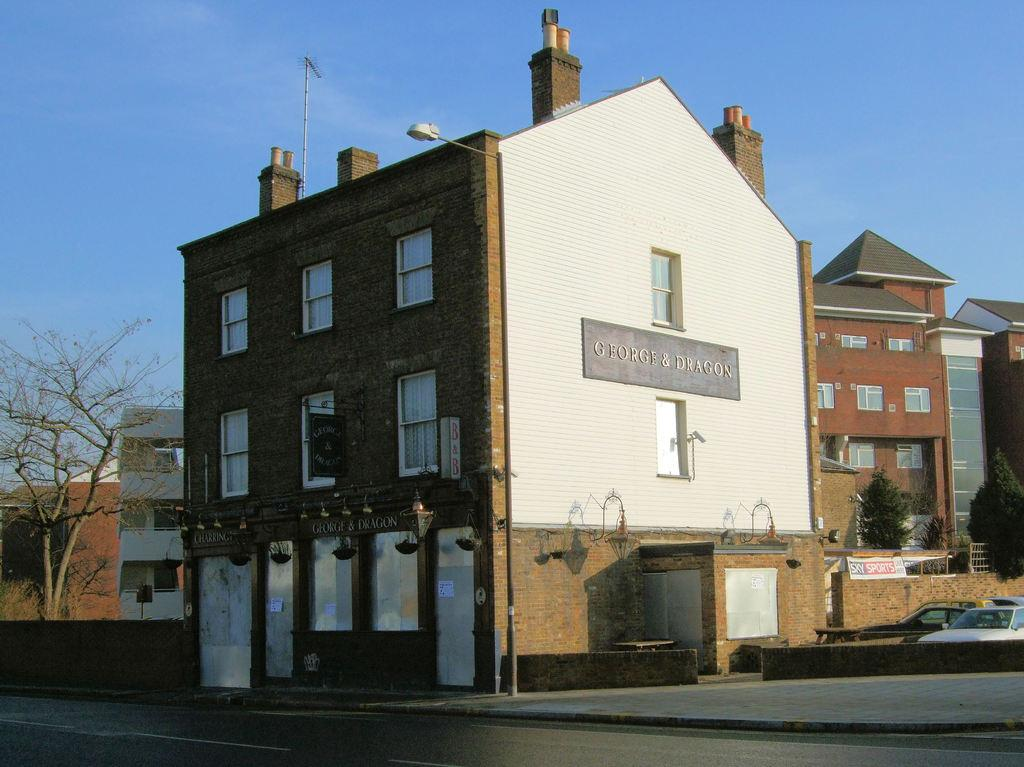What type of structures can be seen in the image? There are buildings in the image. What natural elements are present in the image? There are trees in the image. What man-made objects can be seen in the image? There are vehicles in the image. What architectural feature is visible in the image? There is a skylight in the image. What type of objects are present in the image? There are boards in the image. What is written on the boards? Something is written on the boards. Can you tell me how many balls are bouncing on the tramp in the image? There is no tramp or ball present in the image. What type of grip is required to hold the objects in the image? There are no objects in the image that require a specific grip to hold. 